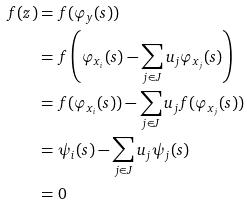<formula> <loc_0><loc_0><loc_500><loc_500>f ( z ) & = f ( \varphi _ { y } ( s ) ) \\ & = f \left ( \varphi _ { x _ { i } } ( s ) - \sum _ { j \in J } u _ { j } \varphi _ { x _ { j } } ( s ) \right ) \\ & = f ( \varphi _ { x _ { i } } ( s ) ) - \sum _ { j \in J } u _ { j } f ( \varphi _ { x _ { j } } ( s ) ) \\ & = \psi _ { i } ( s ) - \sum _ { j \in J } u _ { j } \psi _ { j } ( s ) \\ & = 0</formula> 